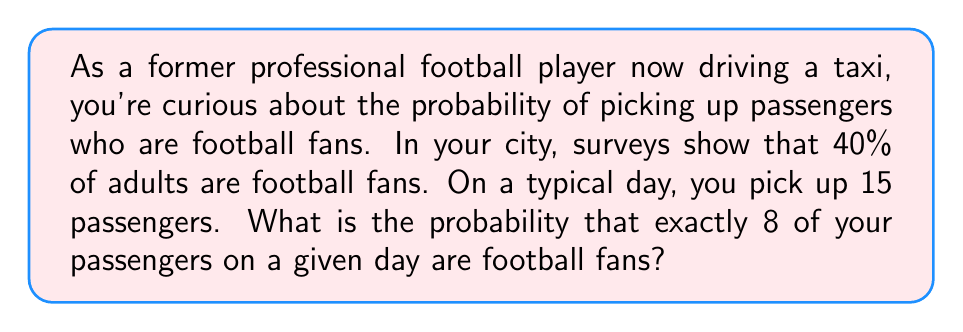Can you answer this question? To solve this problem, we need to use the binomial probability distribution. This distribution is appropriate when we have a fixed number of independent trials (passengers in this case), each with the same probability of success (being a football fan).

Let's define our variables:
$n = 15$ (number of passengers)
$k = 8$ (number of football fans we're interested in)
$p = 0.40$ (probability of a passenger being a football fan)
$q = 1 - p = 0.60$ (probability of a passenger not being a football fan)

The binomial probability formula is:

$$P(X = k) = \binom{n}{k} p^k q^{n-k}$$

Where $\binom{n}{k}$ is the binomial coefficient, calculated as:

$$\binom{n}{k} = \frac{n!}{k!(n-k)!}$$

Let's calculate step by step:

1) First, calculate the binomial coefficient:
   $$\binom{15}{8} = \frac{15!}{8!(15-8)!} = \frac{15!}{8!7!} = 6435$$

2) Now, let's plug everything into the binomial probability formula:
   $$P(X = 8) = 6435 \cdot (0.40)^8 \cdot (0.60)^{15-8}$$
   $$= 6435 \cdot (0.40)^8 \cdot (0.60)^7$$

3) Calculating this:
   $$= 6435 \cdot 0.00065536 \cdot 0.0279936$$
   $$= 0.1177$$

Therefore, the probability of exactly 8 out of 15 passengers being football fans is approximately 0.1177 or 11.77%.
Answer: $0.1177$ or $11.77\%$ 